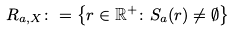Convert formula to latex. <formula><loc_0><loc_0><loc_500><loc_500>R _ { a , X } \colon = \left \{ r \in \mathbb { R } ^ { + } \colon S _ { a } ( r ) \neq \emptyset \right \}</formula> 